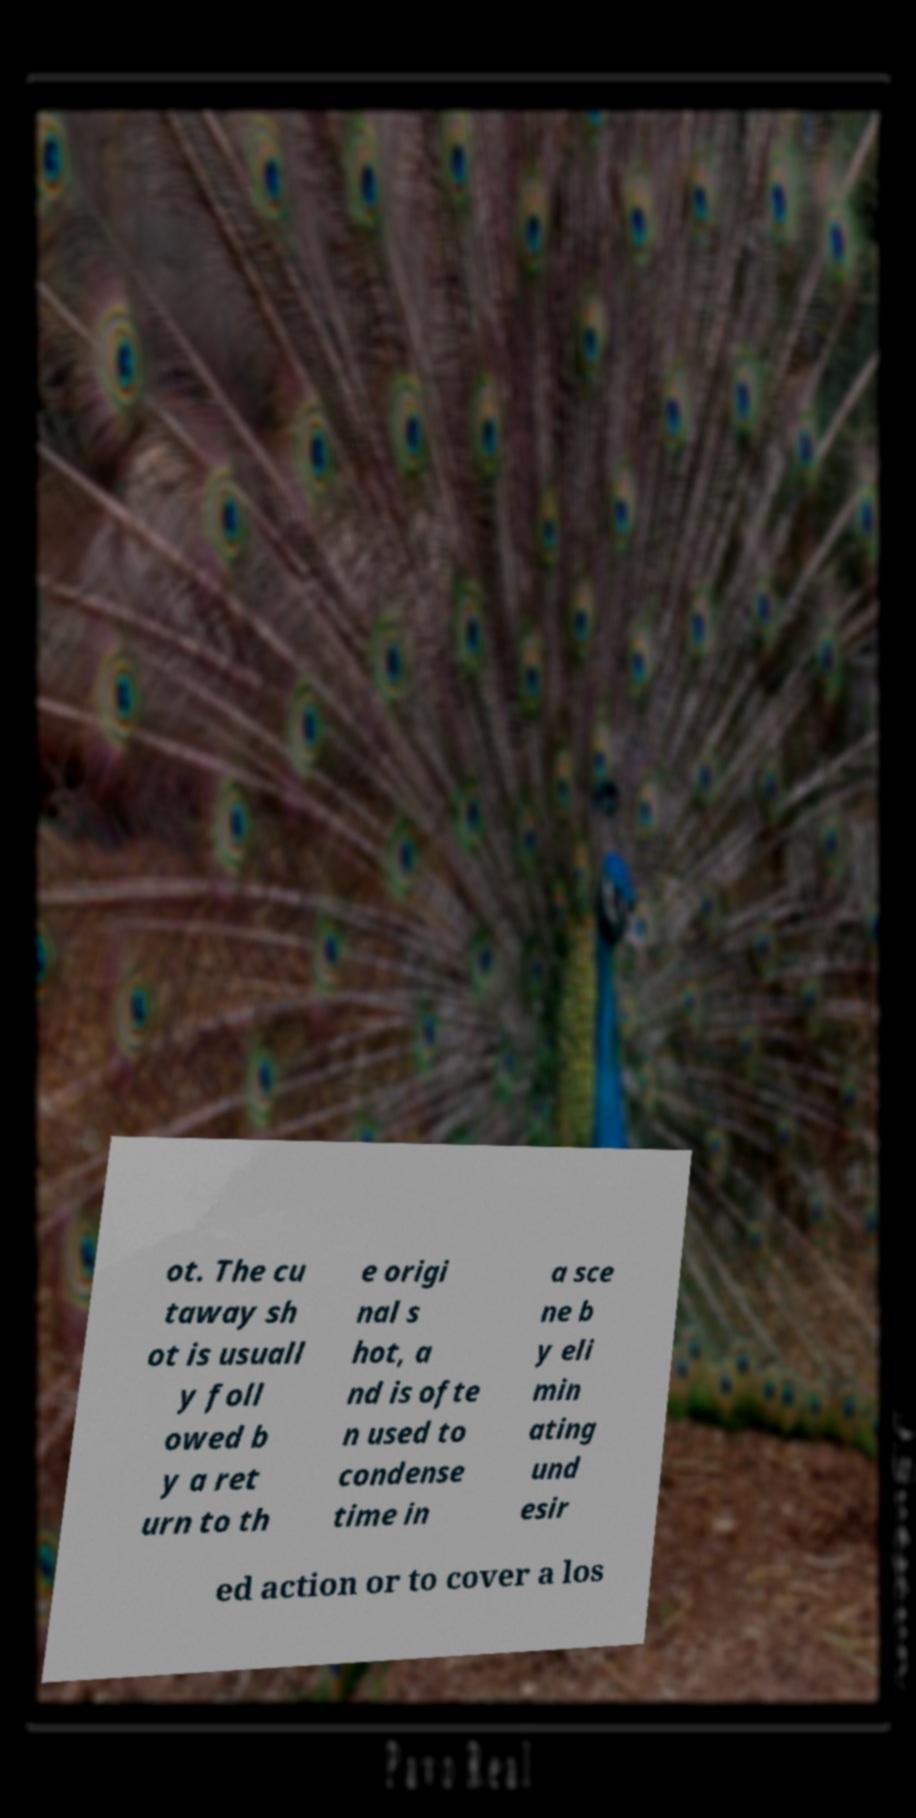There's text embedded in this image that I need extracted. Can you transcribe it verbatim? ot. The cu taway sh ot is usuall y foll owed b y a ret urn to th e origi nal s hot, a nd is ofte n used to condense time in a sce ne b y eli min ating und esir ed action or to cover a los 